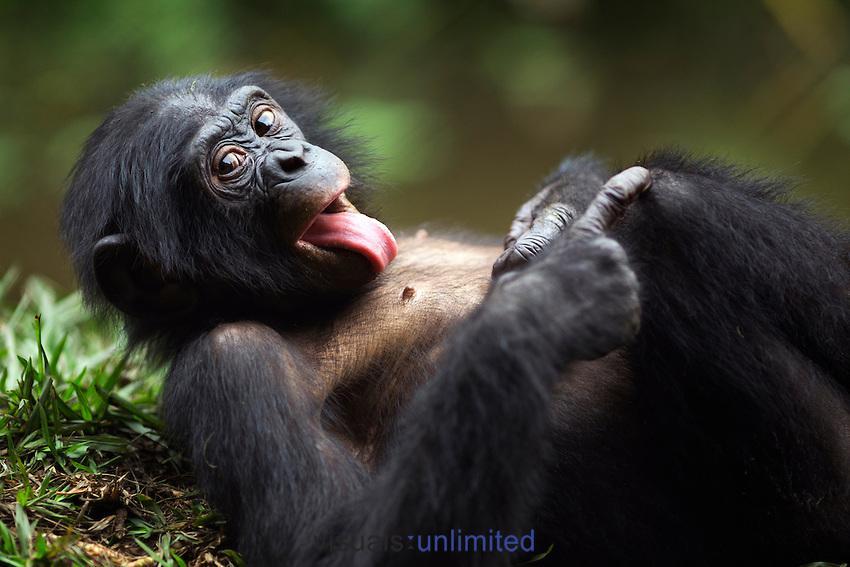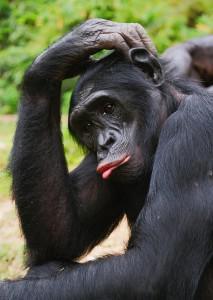The first image is the image on the left, the second image is the image on the right. Evaluate the accuracy of this statement regarding the images: "An image shows an adult and a younger chimp chest to chest in a hugging pose.". Is it true? Answer yes or no. No. The first image is the image on the left, the second image is the image on the right. Considering the images on both sides, is "In one image, two chimpanzees are hugging, while one chimpanzee in a second image has its left arm raised to head level." valid? Answer yes or no. No. 